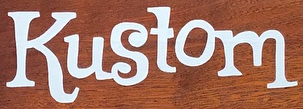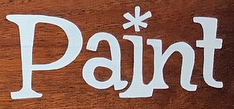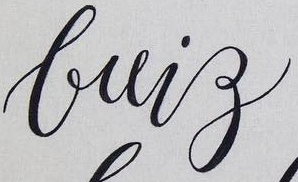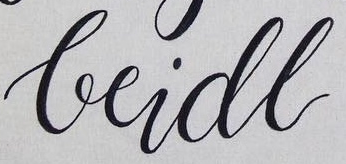What text appears in these images from left to right, separated by a semicolon? Kustom; Paint; brig; beidl 